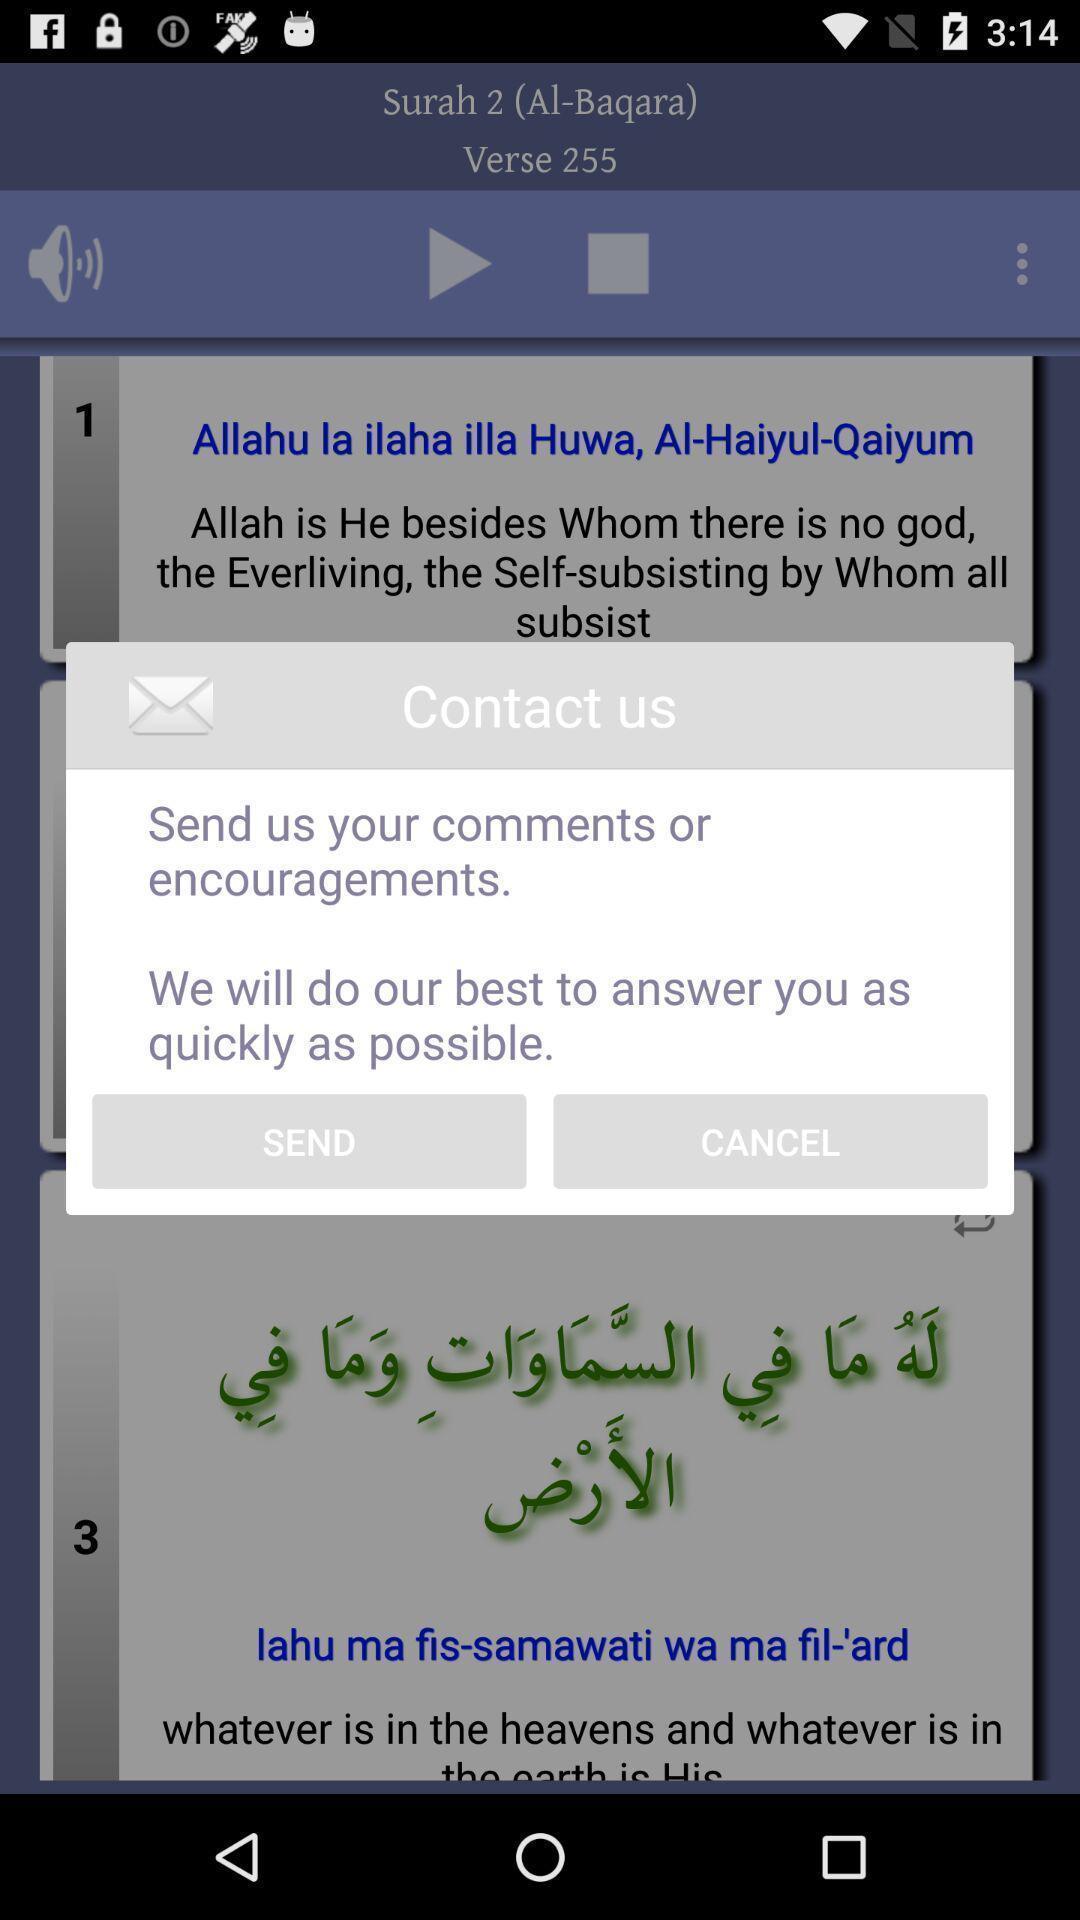Describe the visual elements of this screenshot. Popup to contact in a language translation app. 